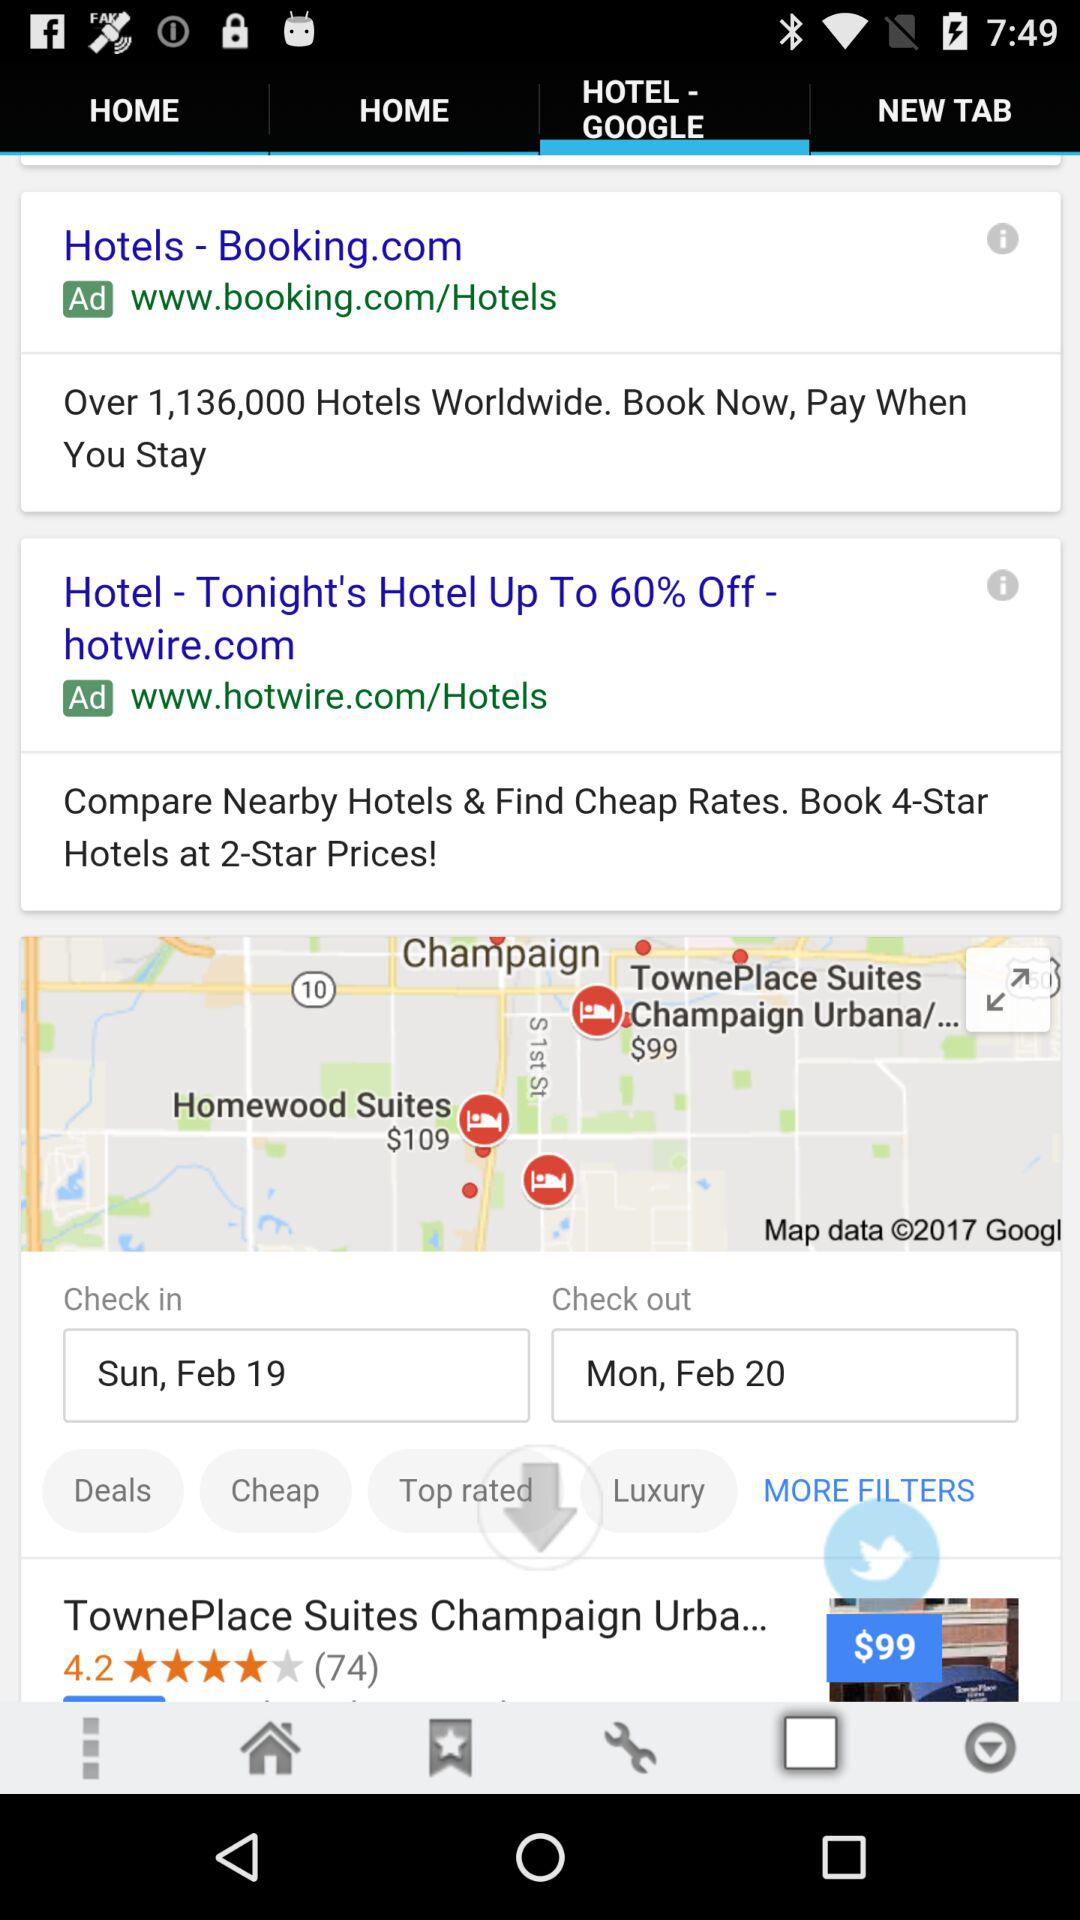By how many people was the "TownePlace Suites Champaign Urbana" reviewed? The hotel was reviewed by 74 people. 